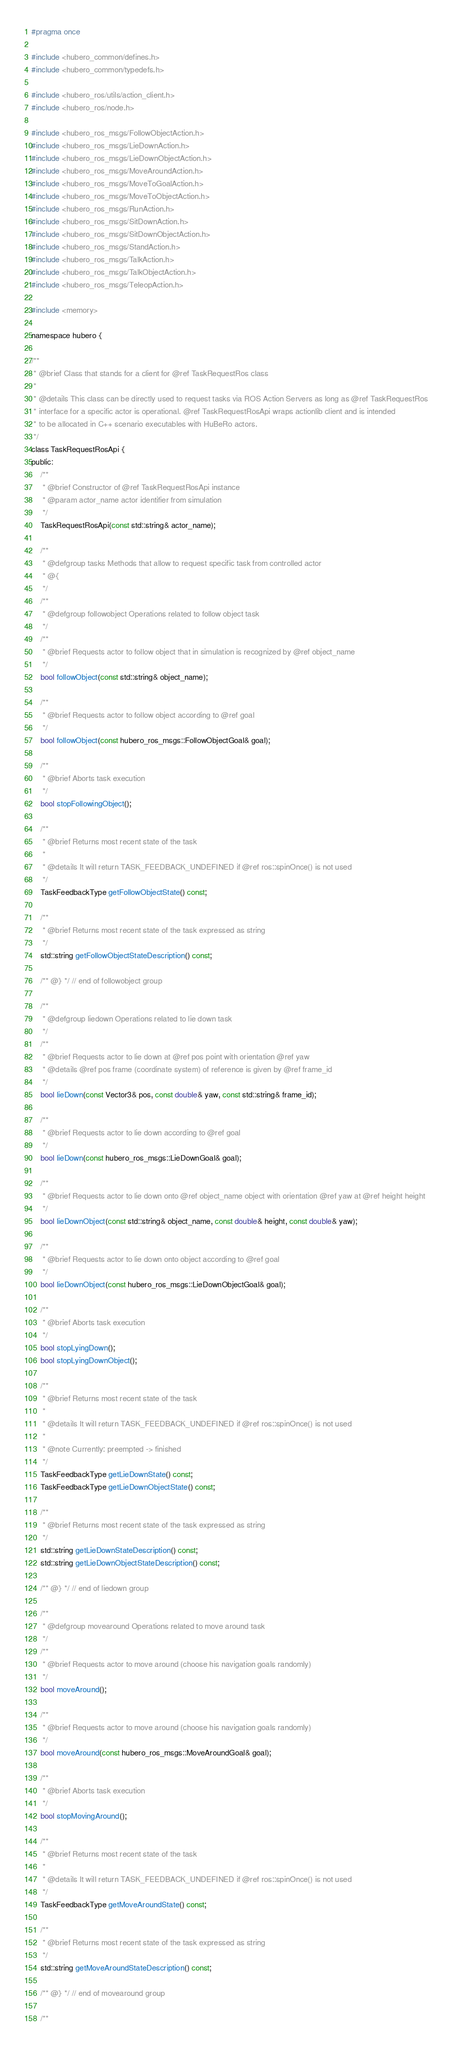Convert code to text. <code><loc_0><loc_0><loc_500><loc_500><_C_>#pragma once

#include <hubero_common/defines.h>
#include <hubero_common/typedefs.h>

#include <hubero_ros/utils/action_client.h>
#include <hubero_ros/node.h>

#include <hubero_ros_msgs/FollowObjectAction.h>
#include <hubero_ros_msgs/LieDownAction.h>
#include <hubero_ros_msgs/LieDownObjectAction.h>
#include <hubero_ros_msgs/MoveAroundAction.h>
#include <hubero_ros_msgs/MoveToGoalAction.h>
#include <hubero_ros_msgs/MoveToObjectAction.h>
#include <hubero_ros_msgs/RunAction.h>
#include <hubero_ros_msgs/SitDownAction.h>
#include <hubero_ros_msgs/SitDownObjectAction.h>
#include <hubero_ros_msgs/StandAction.h>
#include <hubero_ros_msgs/TalkAction.h>
#include <hubero_ros_msgs/TalkObjectAction.h>
#include <hubero_ros_msgs/TeleopAction.h>

#include <memory>

namespace hubero {

/**
 * @brief Class that stands for a client for @ref TaskRequestRos class
 *
 * @details This class can be directly used to request tasks via ROS Action Servers as long as @ref TaskRequestRos
 * interface for a specific actor is operational. @ref TaskRequestRosApi wraps actionlib client and is intended
 * to be allocated in C++ scenario executables with HuBeRo actors.
 */
class TaskRequestRosApi {
public:
	/**
	 * @brief Constructor of @ref TaskRequestRosApi instance
	 * @param actor_name actor identifier from simulation
	 */
	TaskRequestRosApi(const std::string& actor_name);

	/**
	 * @defgroup tasks Methods that allow to request specific task from controlled actor
	 * @{
	 */
	/**
	 * @defgroup followobject Operations related to follow object task
	 */
	/**
	 * @brief Requests actor to follow object that in simulation is recognized by @ref object_name
	 */
	bool followObject(const std::string& object_name);

	/**
	 * @brief Requests actor to follow object according to @ref goal
	 */
	bool followObject(const hubero_ros_msgs::FollowObjectGoal& goal);

	/**
	 * @brief Aborts task execution
	 */
	bool stopFollowingObject();

	/**
	 * @brief Returns most recent state of the task
	 *
	 * @details It will return TASK_FEEDBACK_UNDEFINED if @ref ros::spinOnce() is not used
	 */
	TaskFeedbackType getFollowObjectState() const;

	/**
	 * @brief Returns most recent state of the task expressed as string
	 */
	std::string getFollowObjectStateDescription() const;

	/** @} */ // end of followobject group

	/**
	 * @defgroup liedown Operations related to lie down task
	 */
	/**
	 * @brief Requests actor to lie down at @ref pos point with orientation @ref yaw
	 * @details @ref pos frame (coordinate system) of reference is given by @ref frame_id
	 */
	bool lieDown(const Vector3& pos, const double& yaw, const std::string& frame_id);

	/**
	 * @brief Requests actor to lie down according to @ref goal
	 */
	bool lieDown(const hubero_ros_msgs::LieDownGoal& goal);

	/**
	 * @brief Requests actor to lie down onto @ref object_name object with orientation @ref yaw at @ref height height
	 */
	bool lieDownObject(const std::string& object_name, const double& height, const double& yaw);

	/**
	 * @brief Requests actor to lie down onto object according to @ref goal
	 */
	bool lieDownObject(const hubero_ros_msgs::LieDownObjectGoal& goal);

	/**
	 * @brief Aborts task execution
	 */
	bool stopLyingDown();
	bool stopLyingDownObject();

	/**
	 * @brief Returns most recent state of the task
	 *
	 * @details It will return TASK_FEEDBACK_UNDEFINED if @ref ros::spinOnce() is not used
	 *
	 * @note Currently: preempted -> finished
	 */
	TaskFeedbackType getLieDownState() const;
	TaskFeedbackType getLieDownObjectState() const;

	/**
	 * @brief Returns most recent state of the task expressed as string
	 */
	std::string getLieDownStateDescription() const;
	std::string getLieDownObjectStateDescription() const;

	/** @} */ // end of liedown group

	/**
	 * @defgroup movearound Operations related to move around task
	 */
	/**
	 * @brief Requests actor to move around (choose his navigation goals randomly)
	 */
	bool moveAround();

	/**
	 * @brief Requests actor to move around (choose his navigation goals randomly)
	 */
	bool moveAround(const hubero_ros_msgs::MoveAroundGoal& goal);

	/**
	 * @brief Aborts task execution
	 */
	bool stopMovingAround();

	/**
	 * @brief Returns most recent state of the task
	 *
	 * @details It will return TASK_FEEDBACK_UNDEFINED if @ref ros::spinOnce() is not used
	 */
	TaskFeedbackType getMoveAroundState() const;

	/**
	 * @brief Returns most recent state of the task expressed as string
	 */
	std::string getMoveAroundStateDescription() const;

	/** @} */ // end of movearound group

	/**</code> 